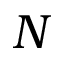<formula> <loc_0><loc_0><loc_500><loc_500>N</formula> 